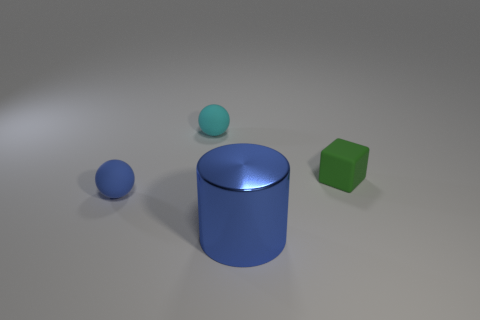Are there fewer metal objects that are to the left of the large blue thing than tiny red rubber balls?
Provide a succinct answer. No. Do the object to the right of the large blue cylinder and the big blue cylinder have the same material?
Offer a terse response. No. The blue object to the left of the object in front of the tiny matte object that is in front of the cube is what shape?
Your answer should be compact. Sphere. Are there any other green matte blocks that have the same size as the cube?
Provide a succinct answer. No. What size is the green thing?
Ensure brevity in your answer.  Small. How many green blocks have the same size as the cyan matte thing?
Provide a short and direct response. 1. Are there fewer big blue cylinders right of the green matte block than tiny cyan things to the left of the tiny blue sphere?
Offer a terse response. No. There is a object on the left side of the ball behind the blue thing that is behind the metallic thing; how big is it?
Your response must be concise. Small. There is a thing that is both right of the cyan rubber ball and behind the big cylinder; what size is it?
Offer a very short reply. Small. There is a thing to the right of the blue thing that is right of the small blue matte thing; what is its shape?
Provide a short and direct response. Cube. 